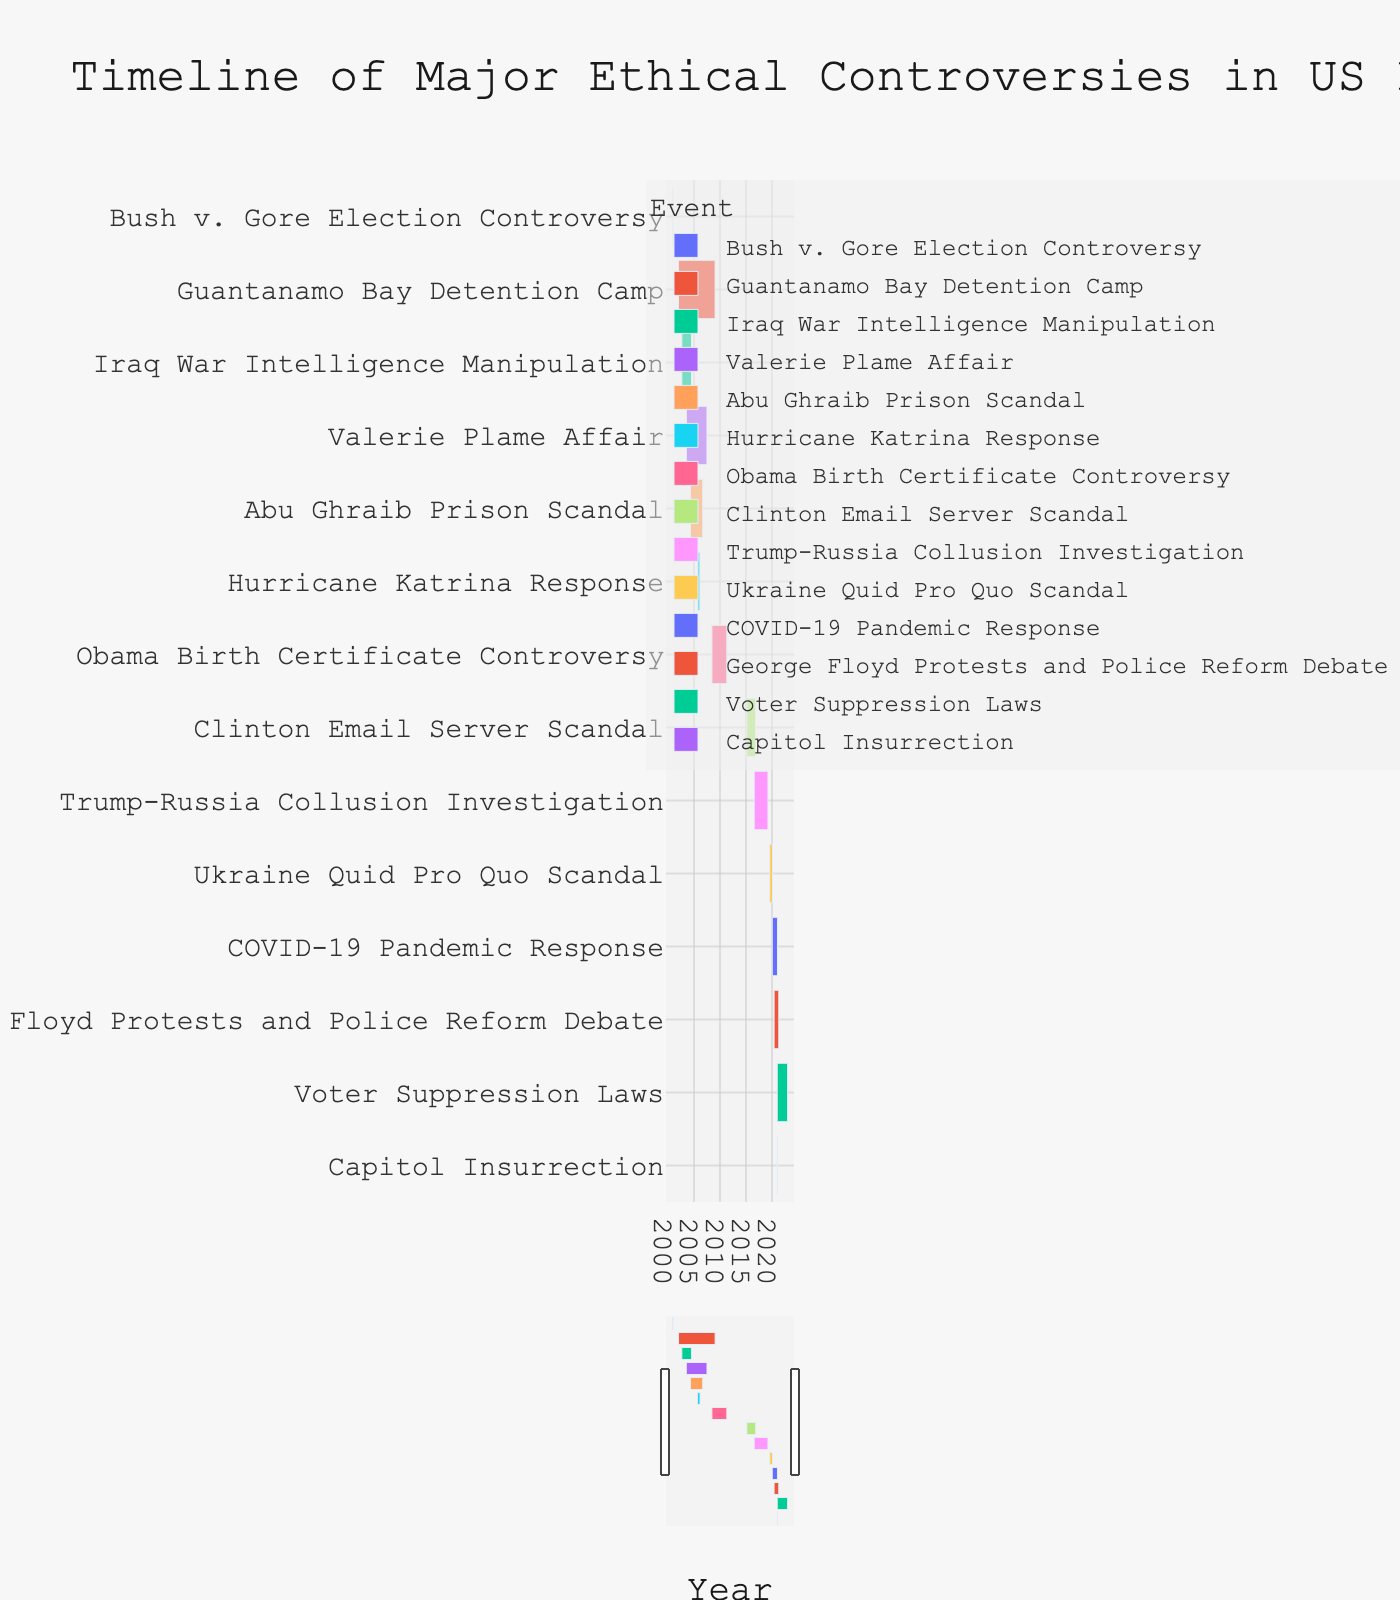What is the title of the chart? The chart title is typically found at the top of the figure. In this case, it reads, "Timeline of Major Ethical Controversies in US Politics (2000-2022)."
Answer: Timeline of Major Ethical Controversies in US Politics (2000-2022) How long did the Iraq War Intelligence Manipulation controversy last? To determine the duration, subtract the start date from the end date. The controversy started on 2002-09-01 and ended on 2004-07-09. Thus, it lasted for 1 year, 10 months, and 8 days.
Answer: 1 year, 10 months, and 8 days Which controversy had the earliest start date? By looking at the start dates on the timeline, the earliest start date is 2000-11-07 for the Bush v. Gore Election Controversy.
Answer: Bush v. Gore Election Controversy Which two controversies overlapped with each other during the period from 2020-01-20 to 2021-01-20? To find the overlaps, identify controversies that share the same timeline. The COVID-19 Pandemic Response (2020-01-20 to 2021-01-20) and George Floyd Protests and Police Reform Debate (2020-05-26 to 2021-04-20) overlap during this period.
Answer: COVID-19 Pandemic Response and George Floyd Protests and Police Reform Debate What is the total number of controversies included in the chart? Count the individual events listed along the y-axis in the figure. There are 14 ethical controversies shown in the timeline.
Answer: 14 Which controversy lasted the longest? To determine the longest-lasting controversy, look for the event with the largest duration on the timeline. The Guantanamo Bay Detention Camp held the longest duration from 2002-01-11 to 2009-01-22.
Answer: Guantanamo Bay Detention Camp How did the duration of the Trump-Russia Collusion Investigation compare to the Hurricane Katrina Response? Calculate the duration of each event by subtracting the start date from the end date. Trump-Russia Collusion Investigation lasted from 2016-07-31 to 2019-03-22 (2 years, 7 months, 23 days). Hurricane Katrina Response lasted from 2005-08-29 to 2006-02-28 (6 months). The Trump-Russia investigation lasted significantly longer.
Answer: Trump-Russia Collusion Investigation lasted longer What is the median duration of all the controversies? List all the durations and find the middle value. If the number of durations is even, average the two middle numbers. Calculated durations are:
- Bush v. Gore: 1 month, 5 days
- Iraq War: 1 year, 10 months, 8 days
- Abu Ghraib: 2 years, 4 months, 9 days
- Hurricane Katrina: 6 months
- Valerie Plame: 4 years
- Guantanamo Bay: 7 years, 11 days
- Obama Birth Certificate: 2 years, 10 months, 14 days
- Clinton Email: 1 year, 8 months, 4 days
- Trump-Russia: 2 years, 7 months, 23 days
- Ukraine Quid Pro Quo: 6 months, 11 days
- Capitol Insurrection: 14 days
- COVID-19 Response: 1 year
- George Floyd: 10 months, 25 days
- Voter Suppression Laws: 2 years
The median value is between the 7th and 8th durations, so it is the average of 2 years, 7 months, 23 days and 2 years, 10 months, 14 days.
Answer: 2 years, 9 months Which controversy occurred entirely within 2021? By looking at the timelines, the only controversy that occurred only within the year 2021 is the Capitol Insurrection, from January 6, 2021, to January 20, 2021.
Answer: Capitol Insurrection 